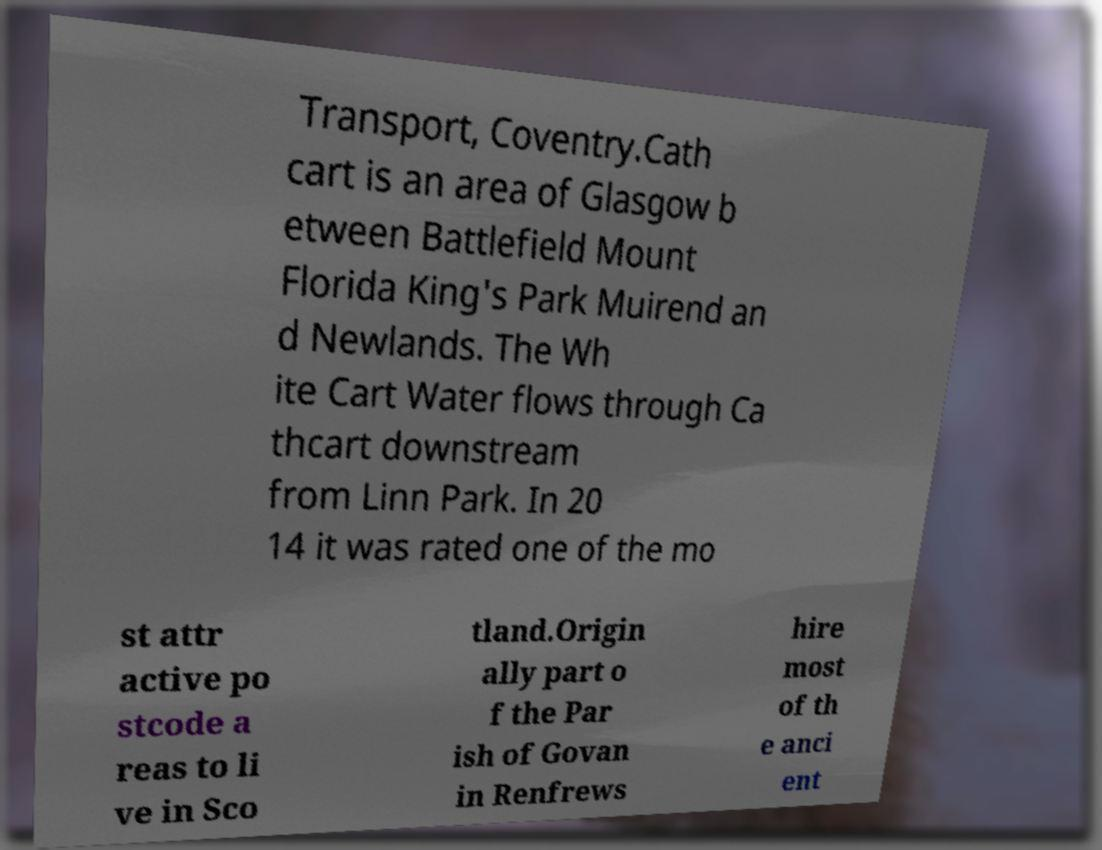Please identify and transcribe the text found in this image. Transport, Coventry.Cath cart is an area of Glasgow b etween Battlefield Mount Florida King's Park Muirend an d Newlands. The Wh ite Cart Water flows through Ca thcart downstream from Linn Park. In 20 14 it was rated one of the mo st attr active po stcode a reas to li ve in Sco tland.Origin ally part o f the Par ish of Govan in Renfrews hire most of th e anci ent 